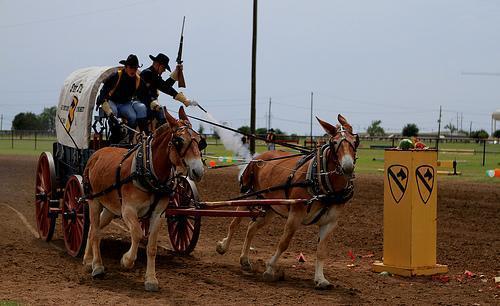How many men are in the photo?
Give a very brief answer. 2. 